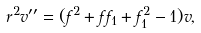Convert formula to latex. <formula><loc_0><loc_0><loc_500><loc_500>r ^ { 2 } v ^ { \prime \prime } = ( f ^ { 2 } + f f _ { 1 } + f _ { 1 } ^ { 2 } - 1 ) v ,</formula> 